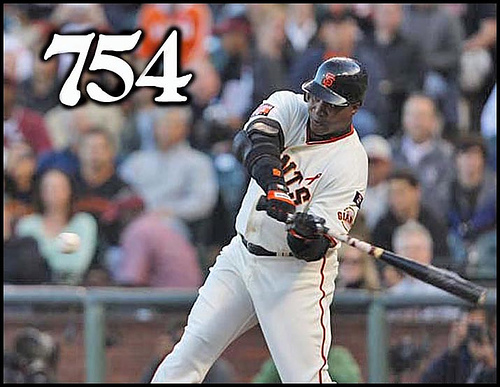<image>What color is the photo? It is ambiguous what color the photo is, it appears to be multi-colored. What color is the photo? I am not sure what color is the photo. It can be seen as multi colored, colored, black, or all different colors. 